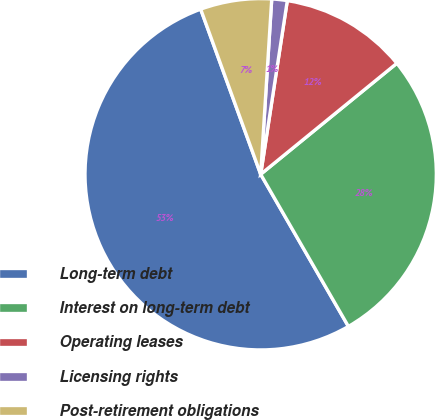Convert chart to OTSL. <chart><loc_0><loc_0><loc_500><loc_500><pie_chart><fcel>Long-term debt<fcel>Interest on long-term debt<fcel>Operating leases<fcel>Licensing rights<fcel>Post-retirement obligations<nl><fcel>52.77%<fcel>27.56%<fcel>11.69%<fcel>1.42%<fcel>6.55%<nl></chart> 